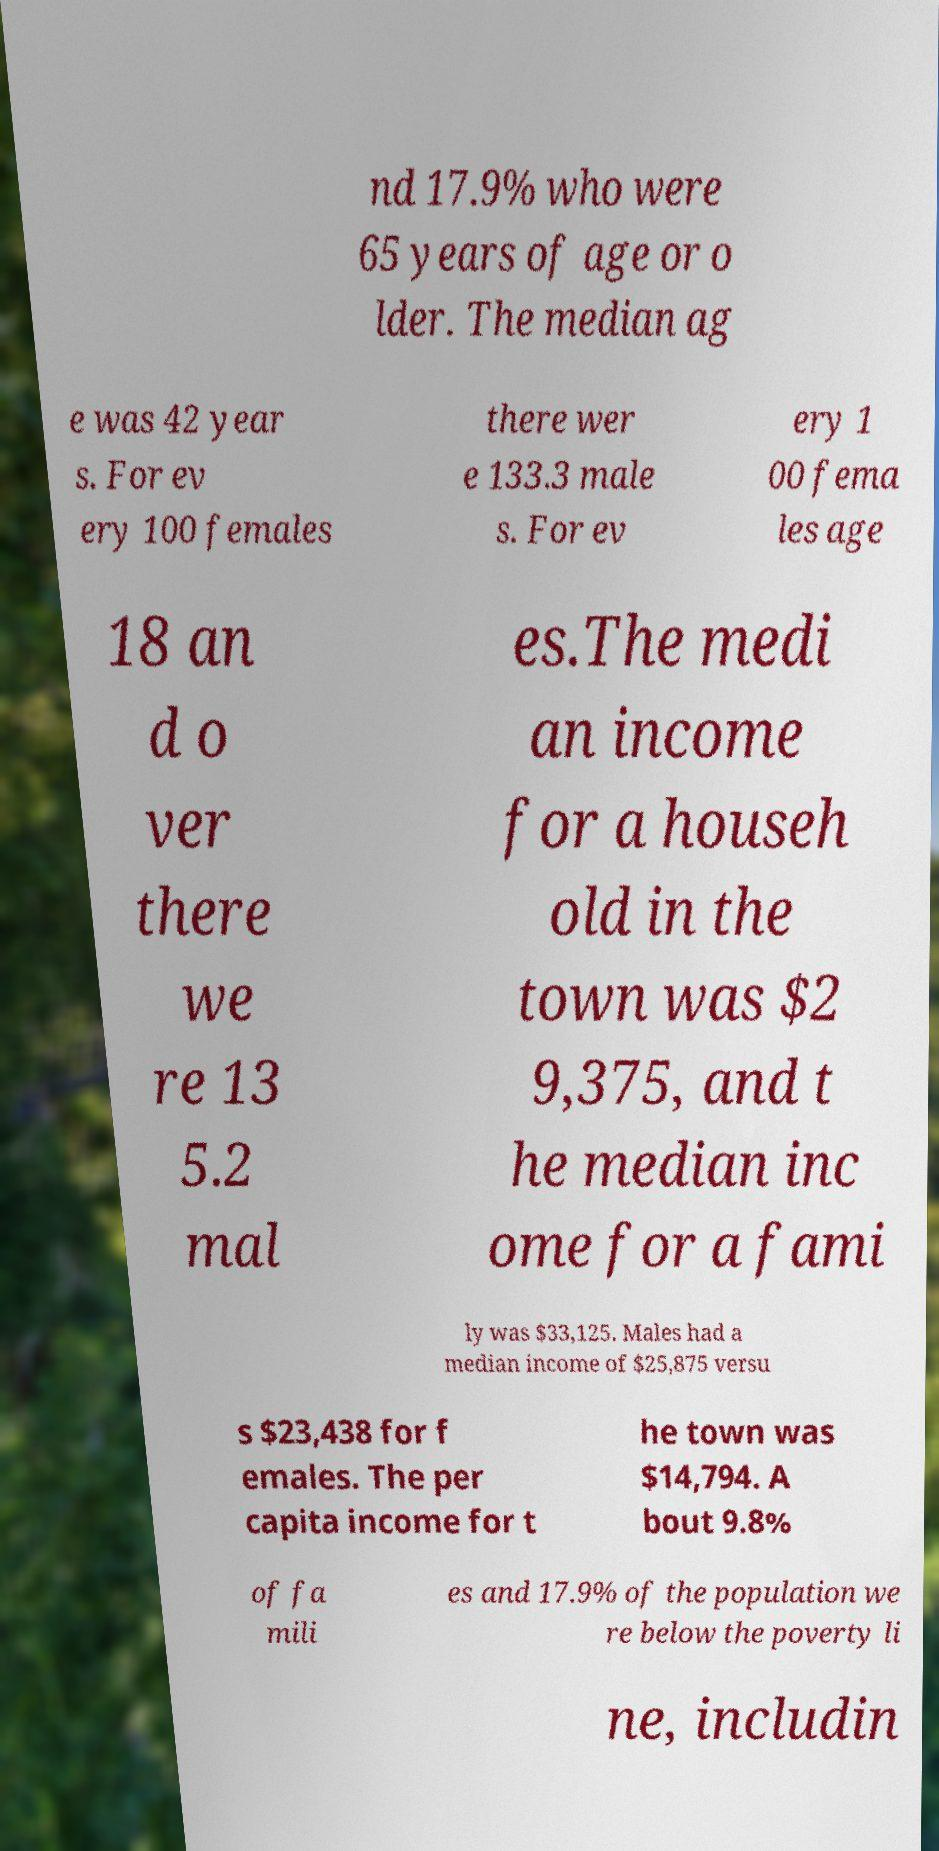Please read and relay the text visible in this image. What does it say? nd 17.9% who were 65 years of age or o lder. The median ag e was 42 year s. For ev ery 100 females there wer e 133.3 male s. For ev ery 1 00 fema les age 18 an d o ver there we re 13 5.2 mal es.The medi an income for a househ old in the town was $2 9,375, and t he median inc ome for a fami ly was $33,125. Males had a median income of $25,875 versu s $23,438 for f emales. The per capita income for t he town was $14,794. A bout 9.8% of fa mili es and 17.9% of the population we re below the poverty li ne, includin 